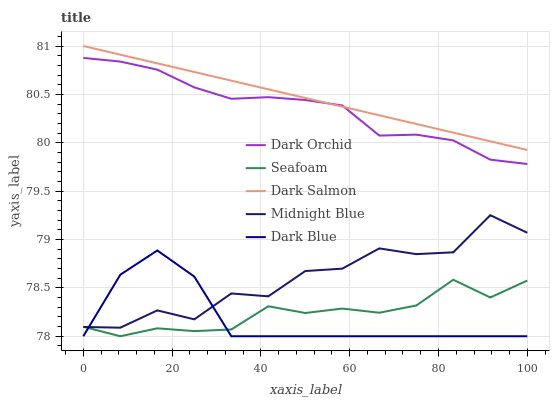Does Dark Blue have the minimum area under the curve?
Answer yes or no. Yes. Does Dark Salmon have the maximum area under the curve?
Answer yes or no. Yes. Does Midnight Blue have the minimum area under the curve?
Answer yes or no. No. Does Midnight Blue have the maximum area under the curve?
Answer yes or no. No. Is Dark Salmon the smoothest?
Answer yes or no. Yes. Is Midnight Blue the roughest?
Answer yes or no. Yes. Is Seafoam the smoothest?
Answer yes or no. No. Is Seafoam the roughest?
Answer yes or no. No. Does Dark Blue have the lowest value?
Answer yes or no. Yes. Does Midnight Blue have the lowest value?
Answer yes or no. No. Does Dark Salmon have the highest value?
Answer yes or no. Yes. Does Midnight Blue have the highest value?
Answer yes or no. No. Is Midnight Blue less than Dark Salmon?
Answer yes or no. Yes. Is Dark Salmon greater than Seafoam?
Answer yes or no. Yes. Does Dark Orchid intersect Dark Salmon?
Answer yes or no. Yes. Is Dark Orchid less than Dark Salmon?
Answer yes or no. No. Is Dark Orchid greater than Dark Salmon?
Answer yes or no. No. Does Midnight Blue intersect Dark Salmon?
Answer yes or no. No. 